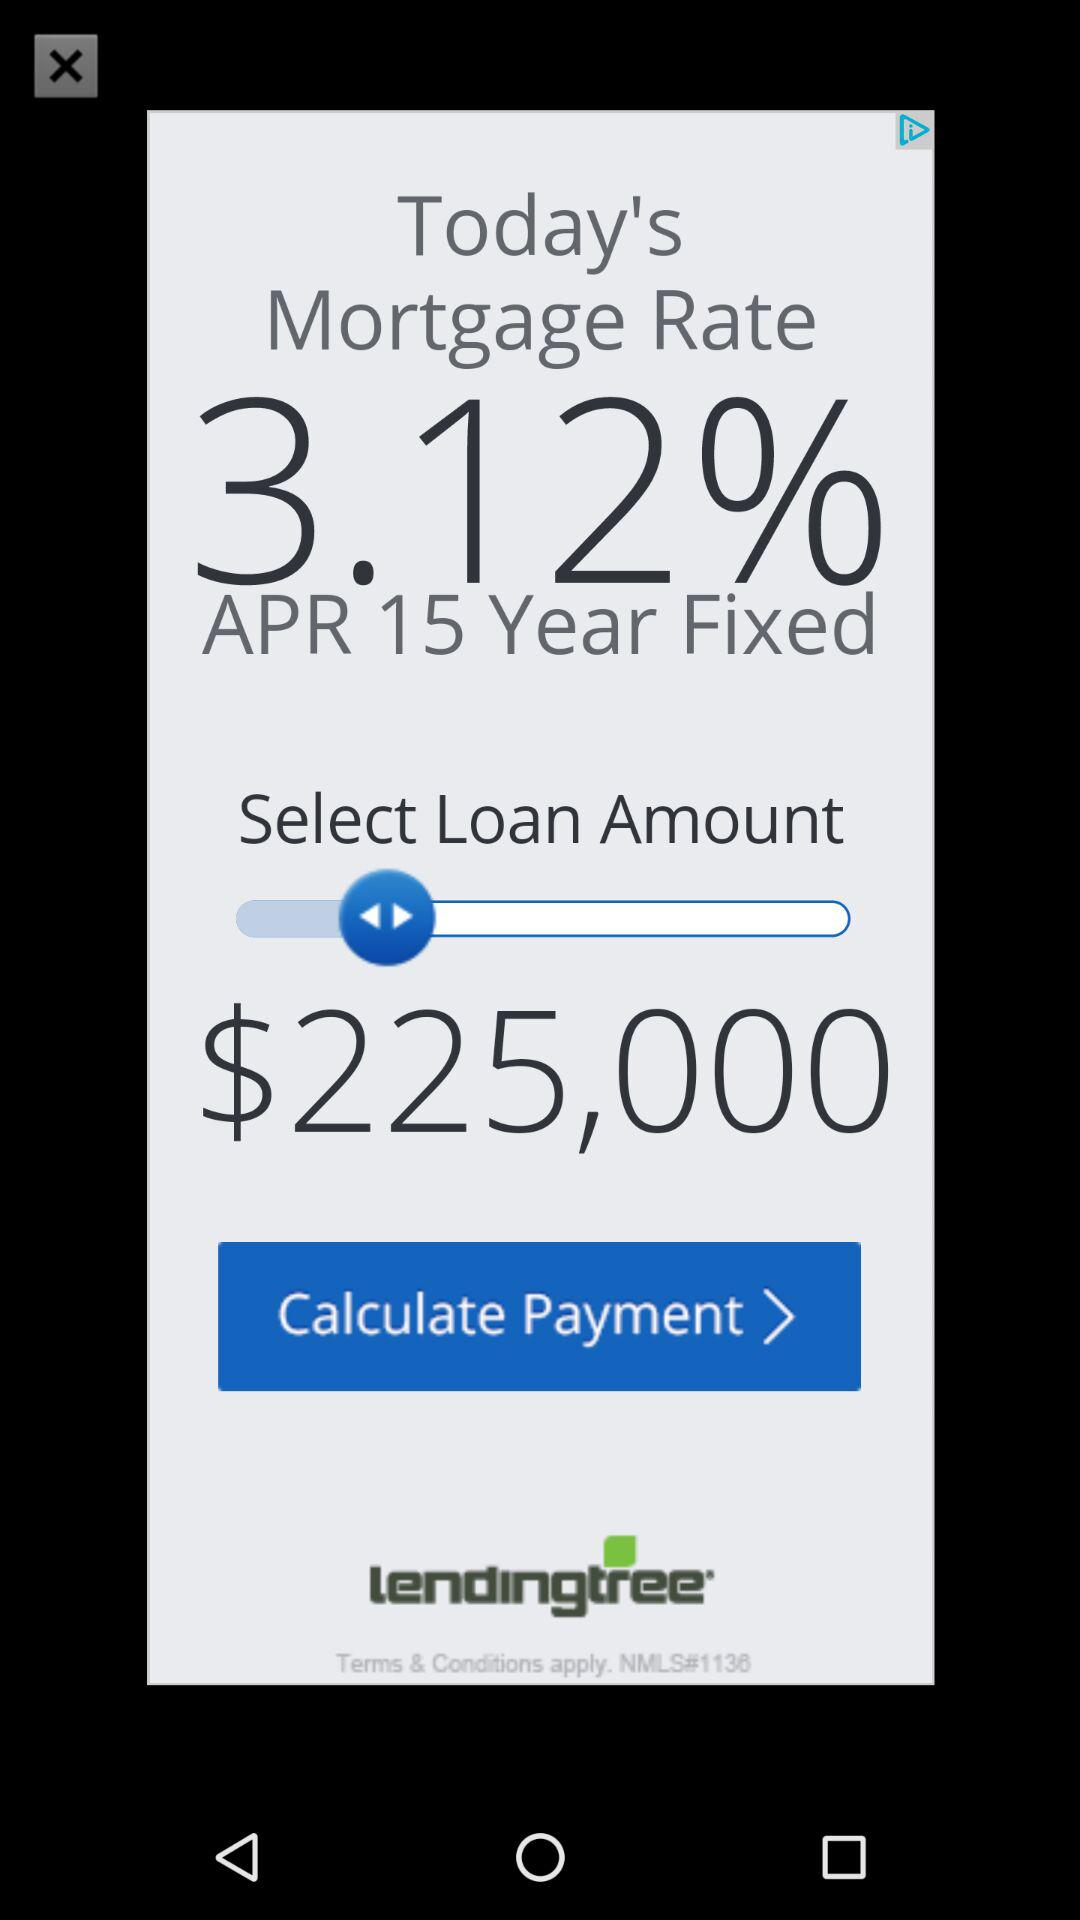What is today's mortgage rate? Today's mortgage rate is 3.12%. 